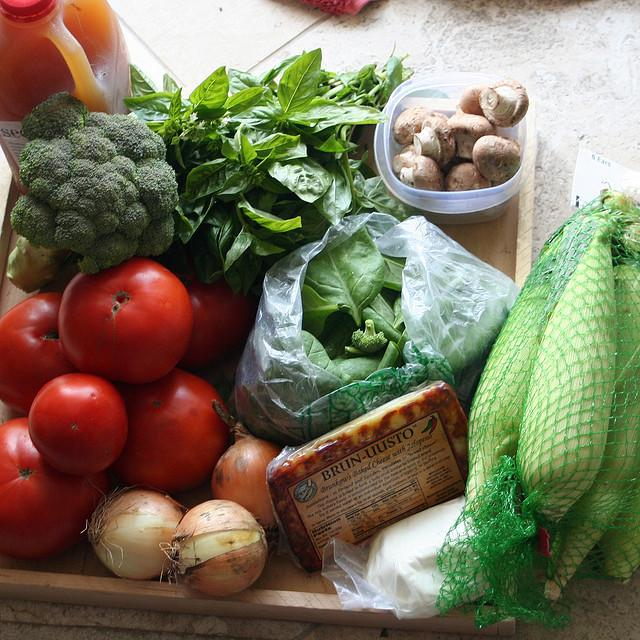What category of food is this? vegetables 